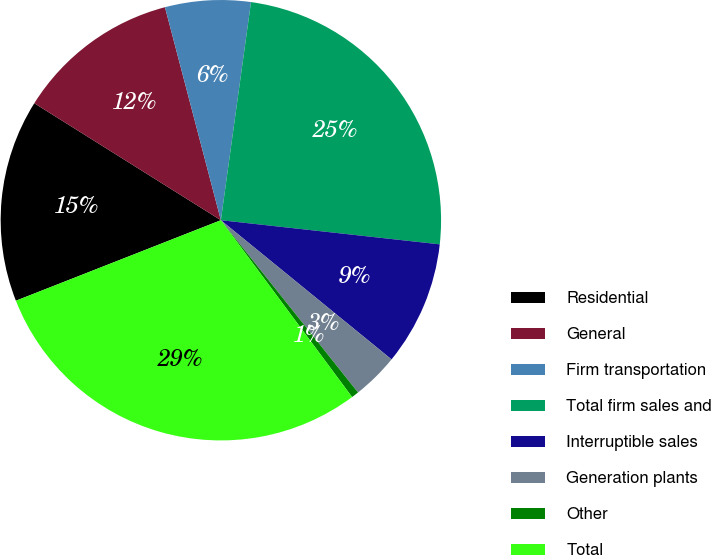Convert chart. <chart><loc_0><loc_0><loc_500><loc_500><pie_chart><fcel>Residential<fcel>General<fcel>Firm transportation<fcel>Total firm sales and<fcel>Interruptible sales<fcel>Generation plants<fcel>Other<fcel>Total<nl><fcel>14.87%<fcel>12.0%<fcel>6.27%<fcel>24.56%<fcel>9.14%<fcel>3.41%<fcel>0.54%<fcel>29.2%<nl></chart> 